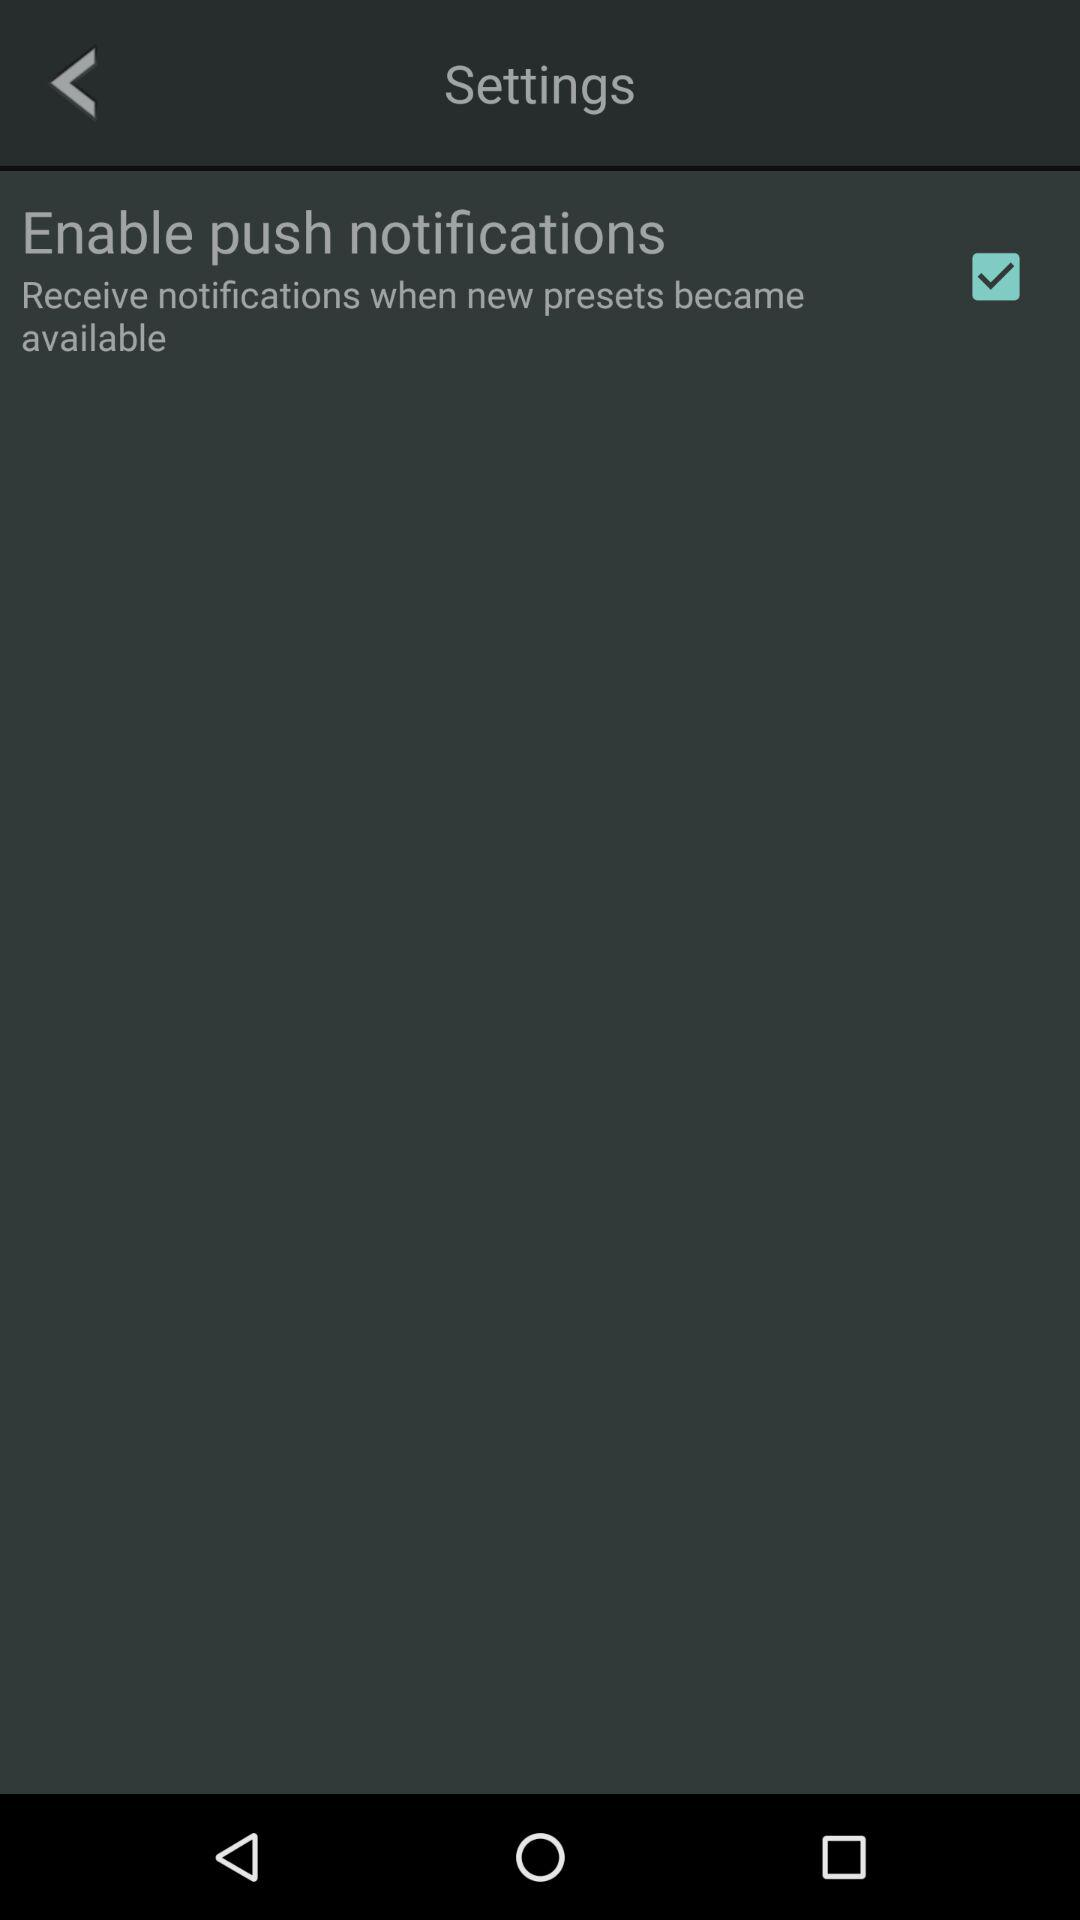What is the status of the "Enable push notifications"? The status of the "Enable push notifications" is "on". 